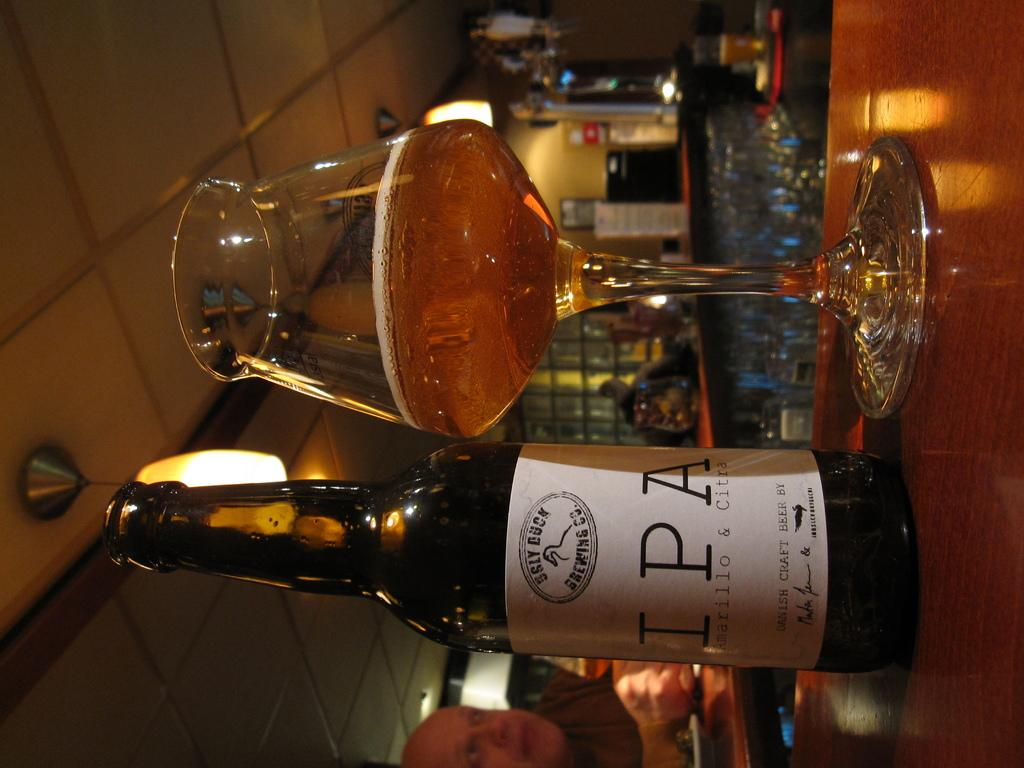Provide a one-sentence caption for the provided image. A bottle of Sly Duck IPA stands next to a glass with beer in it. 